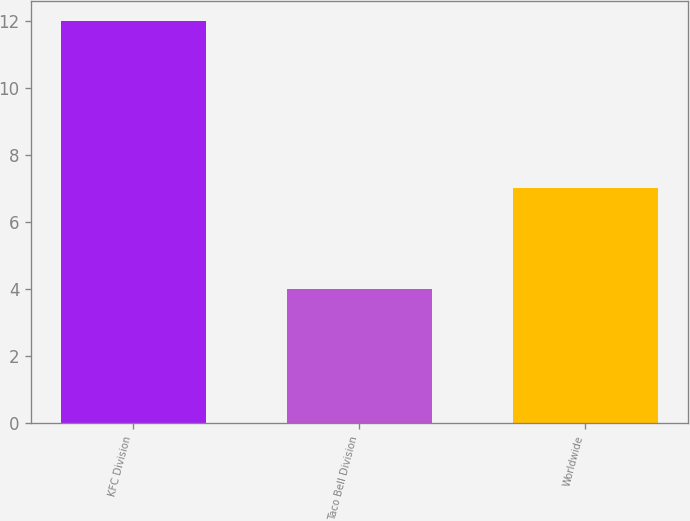<chart> <loc_0><loc_0><loc_500><loc_500><bar_chart><fcel>KFC Division<fcel>Taco Bell Division<fcel>Worldwide<nl><fcel>12<fcel>4<fcel>7<nl></chart> 